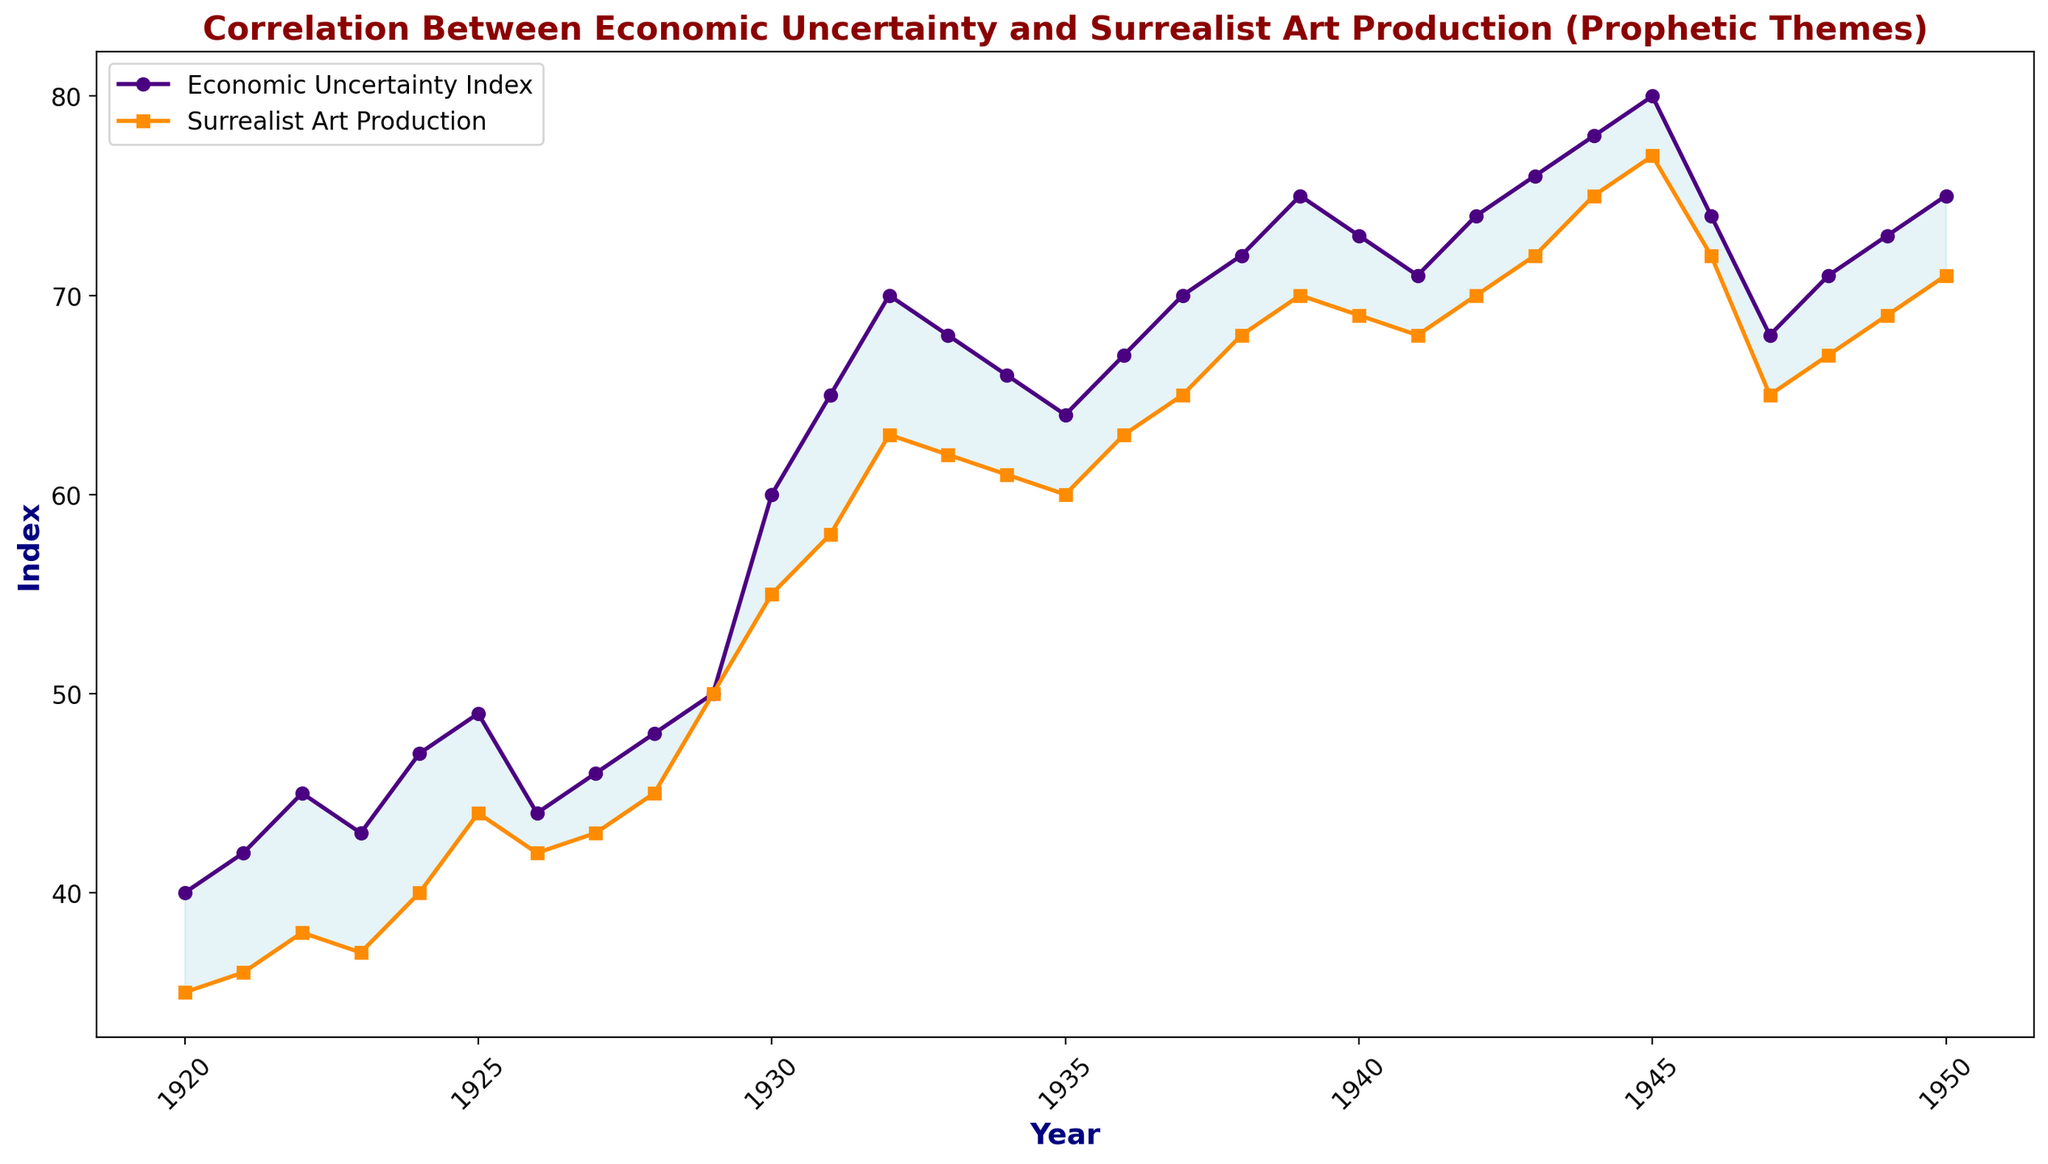What year shows the highest difference between the Economic Uncertainty Index and Surrealist Art Production? To find the year with the highest difference, visually identify the year where the gap between the two lines is the largest. The fill between the lines is a clue; the larger the fill, the greater the difference.
Answer: 1945 Which year has a higher Economic Uncertainty Index than Surrealist Art Production but by the smallest margin? Look for the smallest vertical distance where the economic uncertainty line is above the art production line. This requires checking each year’s two values until the smallest difference is identified.
Answer: 1920 During which period does the Economic Uncertainty Index and Surrealist Art Production trend similarly upward? Visually identify the periods where both lines slope upwards together. A natural location is from the 1920s up until 1930 where both lines generally show an upward trend.
Answer: 1920-1930 What is the overall trend in the production of Surrealist artworks from 1920 to 1950? Observe the line representing Surrealist Art Production from the start to the end of the timeframe. Assess whether it’s predominantly increasing, decreasing, or fluctuating.
Answer: Increasing In which year did both Economic Uncertainty Index and Surrealist Art Production reach near their highest values? Look for the highest peaks of both lines and identify the year where they're closest to those peaks. Both seem to peak around the late 1940s.
Answer: 1945 Calculate the mean Economic Uncertainty Index for the given dataset. Add the Economic Uncertainty Index values from all years, then divide by the total number of years (31). The sum of the values is 1931. Dividing by 31 years, the mean is 1931/31.
Answer: 62.3 Which year has the smallest gap between Economic Uncertainty Index and Surrealist Art Production? Review the filling between the two lines year by year. The gap is smallest where there is little to no fill between the lines.
Answer: 1920 What general observation can be made about the correlation between Economic Uncertainty and Surrealist Art Production? Visually assess the lines' trends, noting whether increases in one generally coincide with increases in the other, indicating a positive correlation. It appears that they both increase and peak around the same times.
Answer: Positive correlation Between 1945 and 1950, does the Economic Uncertainty Index tend to increase or decrease? Visually examine the Economic Uncertainty Index line from 1945 to 1950, noting the general direction.
Answer: Decrease 